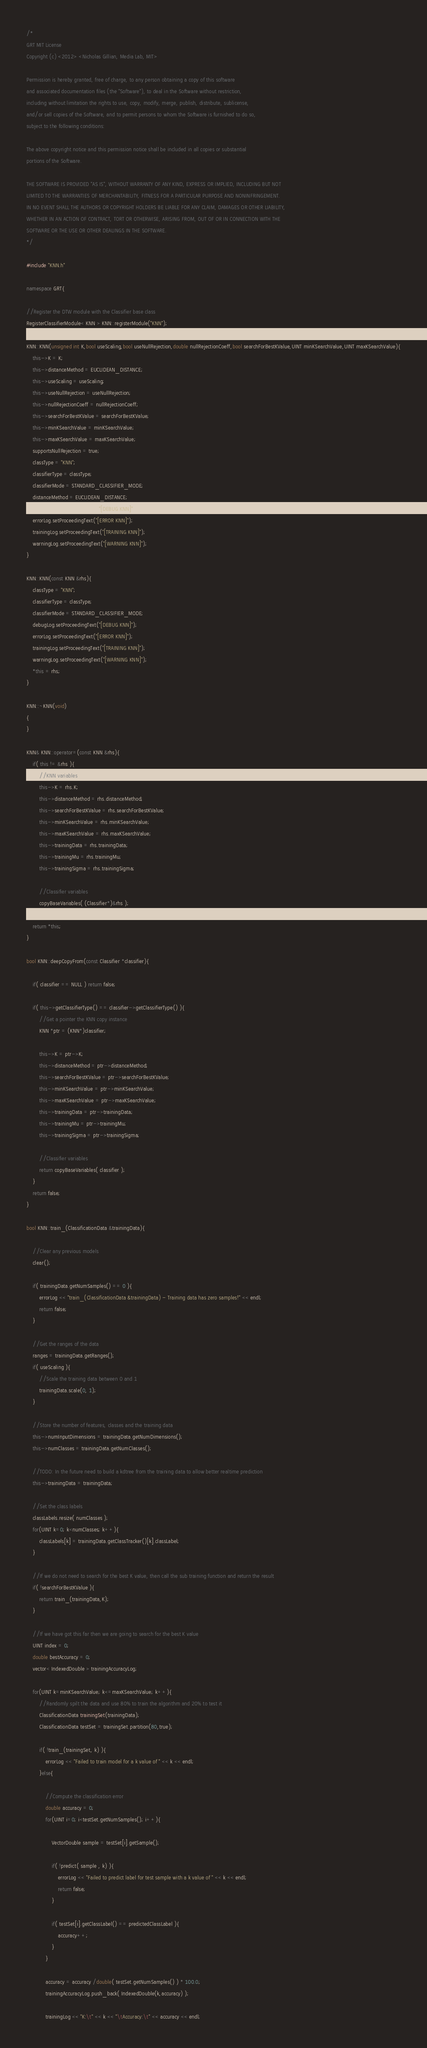Convert code to text. <code><loc_0><loc_0><loc_500><loc_500><_C++_>/*
GRT MIT License
Copyright (c) <2012> <Nicholas Gillian, Media Lab, MIT>

Permission is hereby granted, free of charge, to any person obtaining a copy of this software
and associated documentation files (the "Software"), to deal in the Software without restriction,
including without limitation the rights to use, copy, modify, merge, publish, distribute, sublicense,
and/or sell copies of the Software, and to permit persons to whom the Software is furnished to do so,
subject to the following conditions:

The above copyright notice and this permission notice shall be included in all copies or substantial
portions of the Software.

THE SOFTWARE IS PROVIDED "AS IS", WITHOUT WARRANTY OF ANY KIND, EXPRESS OR IMPLIED, INCLUDING BUT NOT
LIMITED TO THE WARRANTIES OF MERCHANTABILITY, FITNESS FOR A PARTICULAR PURPOSE AND NONINFRINGEMENT.
IN NO EVENT SHALL THE AUTHORS OR COPYRIGHT HOLDERS BE LIABLE FOR ANY CLAIM, DAMAGES OR OTHER LIABILITY,
WHETHER IN AN ACTION OF CONTRACT, TORT OR OTHERWISE, ARISING FROM, OUT OF OR IN CONNECTION WITH THE
SOFTWARE OR THE USE OR OTHER DEALINGS IN THE SOFTWARE.
*/

#include "KNN.h"

namespace GRT{
    
//Register the DTW module with the Classifier base class
RegisterClassifierModule< KNN > KNN::registerModule("KNN");

KNN::KNN(unsigned int K,bool useScaling,bool useNullRejection,double nullRejectionCoeff,bool searchForBestKValue,UINT minKSearchValue,UINT maxKSearchValue){
    this->K = K;
    this->distanceMethod = EUCLIDEAN_DISTANCE;
    this->useScaling = useScaling;
    this->useNullRejection = useNullRejection;
    this->nullRejectionCoeff = nullRejectionCoeff;
    this->searchForBestKValue = searchForBestKValue;
    this->minKSearchValue = minKSearchValue;
    this->maxKSearchValue = maxKSearchValue;
    supportsNullRejection = true;
    classType = "KNN";
    classifierType = classType;
    classifierMode = STANDARD_CLASSIFIER_MODE;
    distanceMethod = EUCLIDEAN_DISTANCE;
    debugLog.setProceedingText("[DEBUG KNN]");
    errorLog.setProceedingText("[ERROR KNN]");
    trainingLog.setProceedingText("[TRAINING KNN]");
    warningLog.setProceedingText("[WARNING KNN]");
}
    
KNN::KNN(const KNN &rhs){
    classType = "KNN";
    classifierType = classType;
    classifierMode = STANDARD_CLASSIFIER_MODE;
    debugLog.setProceedingText("[DEBUG KNN]");
    errorLog.setProceedingText("[ERROR KNN]");
    trainingLog.setProceedingText("[TRAINING KNN]");
    warningLog.setProceedingText("[WARNING KNN]");
    *this = rhs;
}

KNN::~KNN(void)
{
}
    
KNN& KNN::operator=(const KNN &rhs){
    if( this != &rhs ){
        //KNN variables
        this->K = rhs.K;
        this->distanceMethod = rhs.distanceMethod;
        this->searchForBestKValue = rhs.searchForBestKValue;
        this->minKSearchValue = rhs.minKSearchValue;
        this->maxKSearchValue = rhs.maxKSearchValue;
        this->trainingData = rhs.trainingData;
        this->trainingMu = rhs.trainingMu;
        this->trainingSigma = rhs.trainingSigma;
        
        //Classifier variables
        copyBaseVariables( (Classifier*)&rhs );
    }
    return *this;
}
    
bool KNN::deepCopyFrom(const Classifier *classifier){
    
    if( classifier == NULL ) return false;
    
    if( this->getClassifierType() == classifier->getClassifierType() ){
        //Get a pointer the KNN copy instance
        KNN *ptr = (KNN*)classifier;
        
        this->K = ptr->K;
        this->distanceMethod = ptr->distanceMethod;
        this->searchForBestKValue = ptr->searchForBestKValue;
        this->minKSearchValue = ptr->minKSearchValue;
        this->maxKSearchValue = ptr->maxKSearchValue;
        this->trainingData = ptr->trainingData;
        this->trainingMu = ptr->trainingMu;
        this->trainingSigma = ptr->trainingSigma;
        
        //Classifier variables
        return copyBaseVariables( classifier );
    }
    return false;
}

bool KNN::train_(ClassificationData &trainingData){
    
    //Clear any previous models
    clear();
    
    if( trainingData.getNumSamples() == 0 ){
        errorLog << "train_(ClassificationData &trainingData) - Training data has zero samples!" << endl;
        return false;
    }
    
    //Get the ranges of the data
    ranges = trainingData.getRanges();
    if( useScaling ){
        //Scale the training data between 0 and 1
        trainingData.scale(0, 1);
    }
    
    //Store the number of features, classes and the training data
    this->numInputDimensions = trainingData.getNumDimensions();
    this->numClasses = trainingData.getNumClasses();
    
    //TODO: In the future need to build a kdtree from the training data to allow better realtime prediction
    this->trainingData = trainingData;
    
    //Set the class labels
    classLabels.resize( numClasses );
    for(UINT k=0; k<numClasses; k++){
        classLabels[k] = trainingData.getClassTracker()[k].classLabel;
    }

    //If we do not need to search for the best K value, then call the sub training function and return the result
	if( !searchForBestKValue ){
        return train_(trainingData,K);
    }

    //If we have got this far then we are going to search for the best K value
    UINT index = 0;
    double bestAccuracy = 0;
    vector< IndexedDouble > trainingAccuracyLog;

    for(UINT k=minKSearchValue; k<=maxKSearchValue; k++){
        //Randomly spilt the data and use 80% to train the algorithm and 20% to test it
        ClassificationData trainingSet(trainingData);
        ClassificationData testSet = trainingSet.partition(80,true);

        if( !train_(trainingSet, k) ){
            errorLog << "Failed to train model for a k value of " << k << endl;
        }else{

            //Compute the classification error
            double accuracy = 0;
            for(UINT i=0; i<testSet.getNumSamples(); i++){

                VectorDouble sample = testSet[i].getSample();

                if( !predict( sample , k) ){
                    errorLog << "Failed to predict label for test sample with a k value of " << k << endl;
                    return false;
                }

                if( testSet[i].getClassLabel() == predictedClassLabel ){
                    accuracy++;
                }
            }

            accuracy = accuracy /double( testSet.getNumSamples() ) * 100.0;
            trainingAccuracyLog.push_back( IndexedDouble(k,accuracy) );
			
			trainingLog << "K:\t" << k << "\tAccuracy:\t" << accuracy << endl;
</code> 